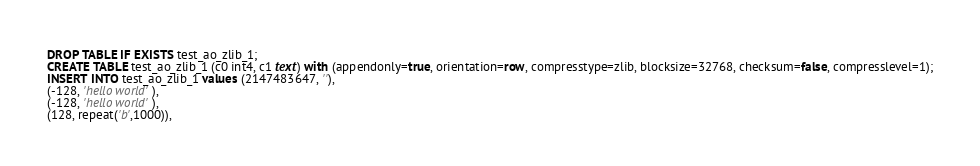Convert code to text. <code><loc_0><loc_0><loc_500><loc_500><_SQL_>DROP TABLE IF EXISTS test_ao_zlib_1;
CREATE TABLE test_ao_zlib_1 (c0 int4, c1 text) with (appendonly=true, orientation=row, compresstype=zlib, blocksize=32768, checksum=false, compresslevel=1);
INSERT INTO test_ao_zlib_1 values (2147483647, ''),
(-128, 'hello world'),
(-128, 'hello world'),
(128, repeat('b',1000)),</code> 